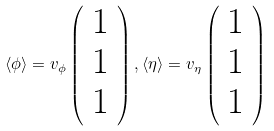Convert formula to latex. <formula><loc_0><loc_0><loc_500><loc_500>\langle \phi \rangle = v _ { \phi } \left ( \begin{array} { c } 1 \\ 1 \\ 1 \end{array} \right ) , \langle \eta \rangle = v _ { \eta } \left ( \begin{array} { c } 1 \\ 1 \\ 1 \end{array} \right )</formula> 